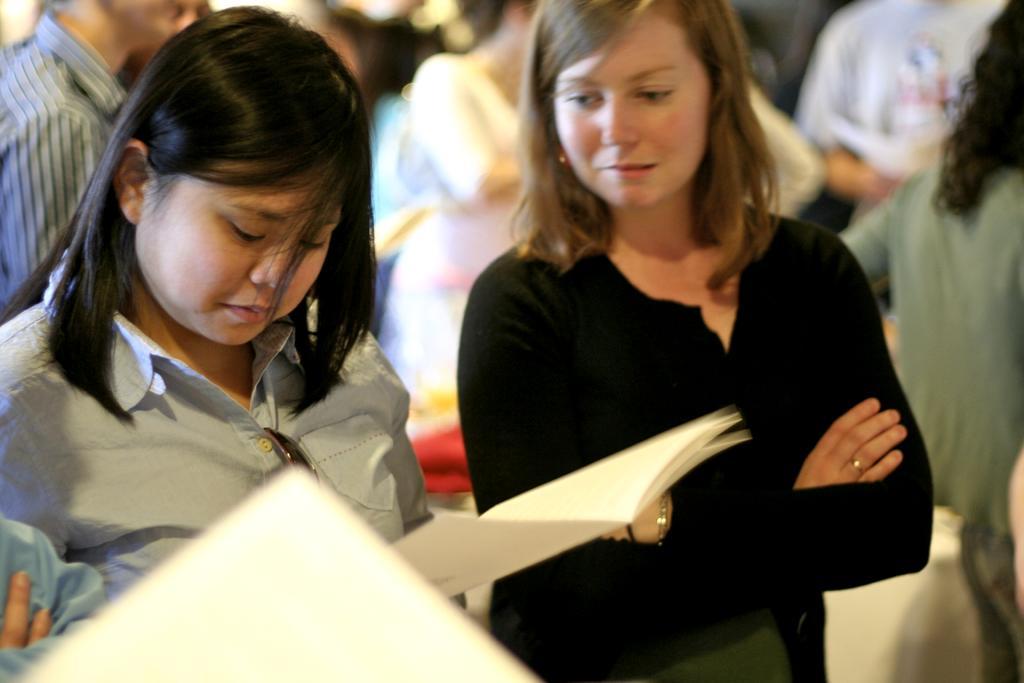How would you summarize this image in a sentence or two? In the image there are two women the foreground and the first woman is holding some book, behind them there are some other people. 